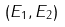Convert formula to latex. <formula><loc_0><loc_0><loc_500><loc_500>( E _ { 1 } , E _ { 2 } )</formula> 